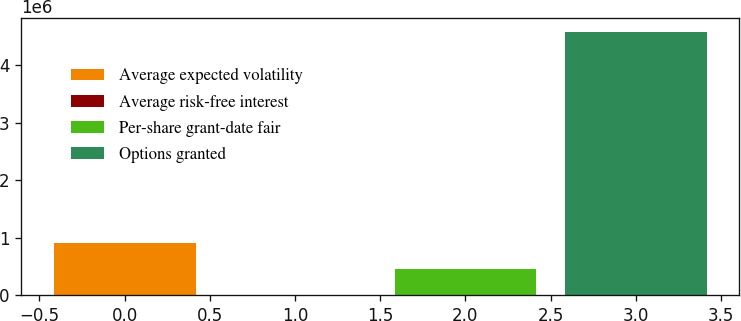Convert chart. <chart><loc_0><loc_0><loc_500><loc_500><bar_chart><fcel>Average expected volatility<fcel>Average risk-free interest<fcel>Per-share grant-date fair<fcel>Options granted<nl><fcel>916103<fcel>3.2<fcel>458053<fcel>4.5805e+06<nl></chart> 